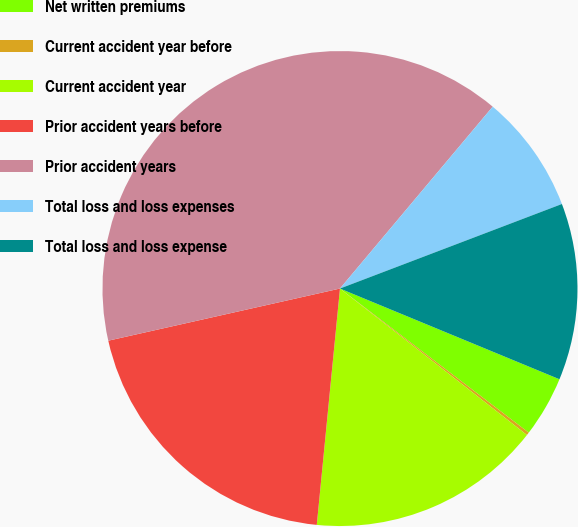<chart> <loc_0><loc_0><loc_500><loc_500><pie_chart><fcel>Net written premiums<fcel>Current accident year before<fcel>Current accident year<fcel>Prior accident years before<fcel>Prior accident years<fcel>Total loss and loss expenses<fcel>Total loss and loss expense<nl><fcel>4.14%<fcel>0.2%<fcel>15.98%<fcel>19.92%<fcel>39.64%<fcel>8.09%<fcel>12.03%<nl></chart> 